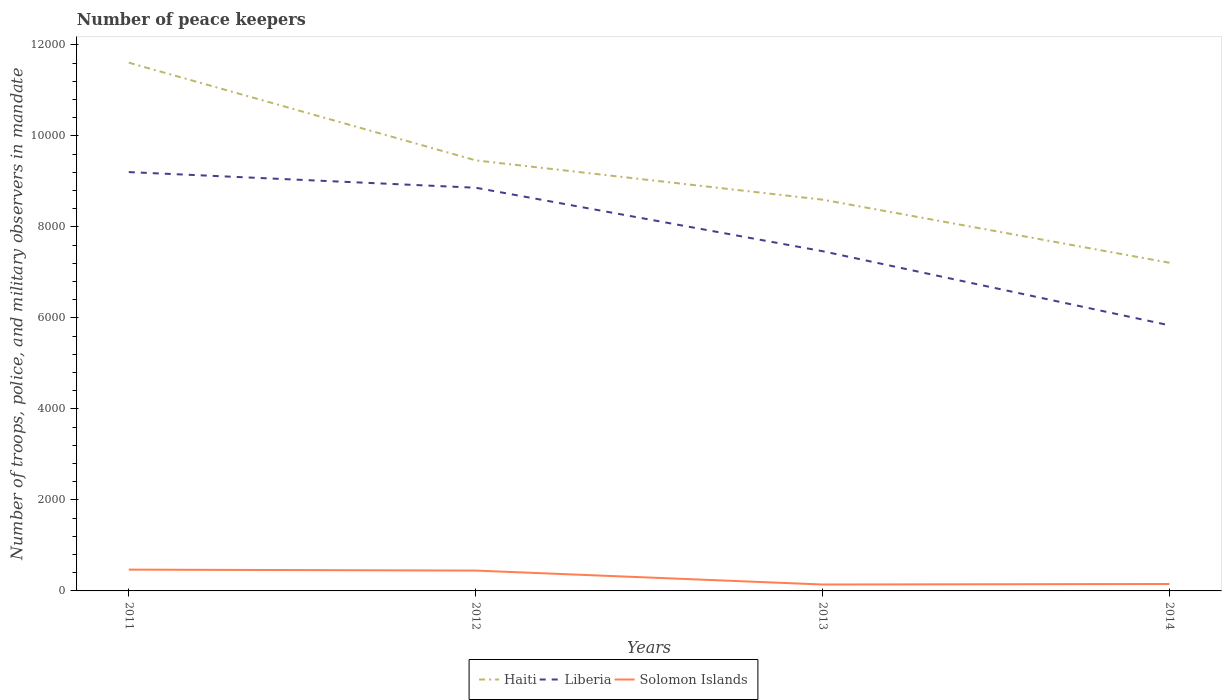Does the line corresponding to Haiti intersect with the line corresponding to Solomon Islands?
Offer a terse response. No. Is the number of lines equal to the number of legend labels?
Your answer should be very brief. Yes. Across all years, what is the maximum number of peace keepers in in Solomon Islands?
Keep it short and to the point. 141. In which year was the number of peace keepers in in Liberia maximum?
Ensure brevity in your answer.  2014. What is the total number of peace keepers in in Liberia in the graph?
Provide a short and direct response. 1395. What is the difference between the highest and the second highest number of peace keepers in in Solomon Islands?
Your answer should be very brief. 327. What is the difference between the highest and the lowest number of peace keepers in in Liberia?
Your answer should be compact. 2. What is the difference between two consecutive major ticks on the Y-axis?
Provide a short and direct response. 2000. Are the values on the major ticks of Y-axis written in scientific E-notation?
Your response must be concise. No. Does the graph contain any zero values?
Ensure brevity in your answer.  No. Does the graph contain grids?
Your answer should be compact. No. Where does the legend appear in the graph?
Your answer should be very brief. Bottom center. What is the title of the graph?
Your answer should be compact. Number of peace keepers. Does "Fragile and conflict affected situations" appear as one of the legend labels in the graph?
Your answer should be very brief. No. What is the label or title of the Y-axis?
Your answer should be compact. Number of troops, police, and military observers in mandate. What is the Number of troops, police, and military observers in mandate of Haiti in 2011?
Provide a succinct answer. 1.16e+04. What is the Number of troops, police, and military observers in mandate in Liberia in 2011?
Your answer should be compact. 9206. What is the Number of troops, police, and military observers in mandate in Solomon Islands in 2011?
Keep it short and to the point. 468. What is the Number of troops, police, and military observers in mandate in Haiti in 2012?
Your answer should be compact. 9464. What is the Number of troops, police, and military observers in mandate of Liberia in 2012?
Keep it short and to the point. 8862. What is the Number of troops, police, and military observers in mandate of Solomon Islands in 2012?
Make the answer very short. 447. What is the Number of troops, police, and military observers in mandate of Haiti in 2013?
Provide a short and direct response. 8600. What is the Number of troops, police, and military observers in mandate in Liberia in 2013?
Offer a terse response. 7467. What is the Number of troops, police, and military observers in mandate in Solomon Islands in 2013?
Keep it short and to the point. 141. What is the Number of troops, police, and military observers in mandate in Haiti in 2014?
Keep it short and to the point. 7213. What is the Number of troops, police, and military observers in mandate of Liberia in 2014?
Ensure brevity in your answer.  5838. What is the Number of troops, police, and military observers in mandate in Solomon Islands in 2014?
Offer a terse response. 152. Across all years, what is the maximum Number of troops, police, and military observers in mandate in Haiti?
Keep it short and to the point. 1.16e+04. Across all years, what is the maximum Number of troops, police, and military observers in mandate of Liberia?
Offer a terse response. 9206. Across all years, what is the maximum Number of troops, police, and military observers in mandate of Solomon Islands?
Keep it short and to the point. 468. Across all years, what is the minimum Number of troops, police, and military observers in mandate of Haiti?
Provide a succinct answer. 7213. Across all years, what is the minimum Number of troops, police, and military observers in mandate in Liberia?
Make the answer very short. 5838. Across all years, what is the minimum Number of troops, police, and military observers in mandate in Solomon Islands?
Give a very brief answer. 141. What is the total Number of troops, police, and military observers in mandate in Haiti in the graph?
Ensure brevity in your answer.  3.69e+04. What is the total Number of troops, police, and military observers in mandate of Liberia in the graph?
Keep it short and to the point. 3.14e+04. What is the total Number of troops, police, and military observers in mandate in Solomon Islands in the graph?
Your response must be concise. 1208. What is the difference between the Number of troops, police, and military observers in mandate of Haiti in 2011 and that in 2012?
Keep it short and to the point. 2147. What is the difference between the Number of troops, police, and military observers in mandate of Liberia in 2011 and that in 2012?
Your response must be concise. 344. What is the difference between the Number of troops, police, and military observers in mandate in Haiti in 2011 and that in 2013?
Make the answer very short. 3011. What is the difference between the Number of troops, police, and military observers in mandate of Liberia in 2011 and that in 2013?
Provide a succinct answer. 1739. What is the difference between the Number of troops, police, and military observers in mandate in Solomon Islands in 2011 and that in 2013?
Offer a very short reply. 327. What is the difference between the Number of troops, police, and military observers in mandate of Haiti in 2011 and that in 2014?
Keep it short and to the point. 4398. What is the difference between the Number of troops, police, and military observers in mandate in Liberia in 2011 and that in 2014?
Your response must be concise. 3368. What is the difference between the Number of troops, police, and military observers in mandate in Solomon Islands in 2011 and that in 2014?
Ensure brevity in your answer.  316. What is the difference between the Number of troops, police, and military observers in mandate of Haiti in 2012 and that in 2013?
Keep it short and to the point. 864. What is the difference between the Number of troops, police, and military observers in mandate in Liberia in 2012 and that in 2013?
Give a very brief answer. 1395. What is the difference between the Number of troops, police, and military observers in mandate of Solomon Islands in 2012 and that in 2013?
Offer a very short reply. 306. What is the difference between the Number of troops, police, and military observers in mandate in Haiti in 2012 and that in 2014?
Ensure brevity in your answer.  2251. What is the difference between the Number of troops, police, and military observers in mandate in Liberia in 2012 and that in 2014?
Your response must be concise. 3024. What is the difference between the Number of troops, police, and military observers in mandate of Solomon Islands in 2012 and that in 2014?
Your answer should be compact. 295. What is the difference between the Number of troops, police, and military observers in mandate in Haiti in 2013 and that in 2014?
Provide a succinct answer. 1387. What is the difference between the Number of troops, police, and military observers in mandate in Liberia in 2013 and that in 2014?
Give a very brief answer. 1629. What is the difference between the Number of troops, police, and military observers in mandate of Haiti in 2011 and the Number of troops, police, and military observers in mandate of Liberia in 2012?
Make the answer very short. 2749. What is the difference between the Number of troops, police, and military observers in mandate of Haiti in 2011 and the Number of troops, police, and military observers in mandate of Solomon Islands in 2012?
Your answer should be very brief. 1.12e+04. What is the difference between the Number of troops, police, and military observers in mandate in Liberia in 2011 and the Number of troops, police, and military observers in mandate in Solomon Islands in 2012?
Your answer should be very brief. 8759. What is the difference between the Number of troops, police, and military observers in mandate in Haiti in 2011 and the Number of troops, police, and military observers in mandate in Liberia in 2013?
Your response must be concise. 4144. What is the difference between the Number of troops, police, and military observers in mandate of Haiti in 2011 and the Number of troops, police, and military observers in mandate of Solomon Islands in 2013?
Give a very brief answer. 1.15e+04. What is the difference between the Number of troops, police, and military observers in mandate in Liberia in 2011 and the Number of troops, police, and military observers in mandate in Solomon Islands in 2013?
Your answer should be very brief. 9065. What is the difference between the Number of troops, police, and military observers in mandate of Haiti in 2011 and the Number of troops, police, and military observers in mandate of Liberia in 2014?
Provide a succinct answer. 5773. What is the difference between the Number of troops, police, and military observers in mandate in Haiti in 2011 and the Number of troops, police, and military observers in mandate in Solomon Islands in 2014?
Your answer should be compact. 1.15e+04. What is the difference between the Number of troops, police, and military observers in mandate in Liberia in 2011 and the Number of troops, police, and military observers in mandate in Solomon Islands in 2014?
Your answer should be compact. 9054. What is the difference between the Number of troops, police, and military observers in mandate in Haiti in 2012 and the Number of troops, police, and military observers in mandate in Liberia in 2013?
Your response must be concise. 1997. What is the difference between the Number of troops, police, and military observers in mandate in Haiti in 2012 and the Number of troops, police, and military observers in mandate in Solomon Islands in 2013?
Offer a very short reply. 9323. What is the difference between the Number of troops, police, and military observers in mandate of Liberia in 2012 and the Number of troops, police, and military observers in mandate of Solomon Islands in 2013?
Your answer should be compact. 8721. What is the difference between the Number of troops, police, and military observers in mandate of Haiti in 2012 and the Number of troops, police, and military observers in mandate of Liberia in 2014?
Provide a short and direct response. 3626. What is the difference between the Number of troops, police, and military observers in mandate of Haiti in 2012 and the Number of troops, police, and military observers in mandate of Solomon Islands in 2014?
Your answer should be compact. 9312. What is the difference between the Number of troops, police, and military observers in mandate of Liberia in 2012 and the Number of troops, police, and military observers in mandate of Solomon Islands in 2014?
Ensure brevity in your answer.  8710. What is the difference between the Number of troops, police, and military observers in mandate of Haiti in 2013 and the Number of troops, police, and military observers in mandate of Liberia in 2014?
Your response must be concise. 2762. What is the difference between the Number of troops, police, and military observers in mandate of Haiti in 2013 and the Number of troops, police, and military observers in mandate of Solomon Islands in 2014?
Your answer should be very brief. 8448. What is the difference between the Number of troops, police, and military observers in mandate of Liberia in 2013 and the Number of troops, police, and military observers in mandate of Solomon Islands in 2014?
Your response must be concise. 7315. What is the average Number of troops, police, and military observers in mandate of Haiti per year?
Provide a succinct answer. 9222. What is the average Number of troops, police, and military observers in mandate in Liberia per year?
Make the answer very short. 7843.25. What is the average Number of troops, police, and military observers in mandate in Solomon Islands per year?
Give a very brief answer. 302. In the year 2011, what is the difference between the Number of troops, police, and military observers in mandate in Haiti and Number of troops, police, and military observers in mandate in Liberia?
Give a very brief answer. 2405. In the year 2011, what is the difference between the Number of troops, police, and military observers in mandate in Haiti and Number of troops, police, and military observers in mandate in Solomon Islands?
Keep it short and to the point. 1.11e+04. In the year 2011, what is the difference between the Number of troops, police, and military observers in mandate of Liberia and Number of troops, police, and military observers in mandate of Solomon Islands?
Keep it short and to the point. 8738. In the year 2012, what is the difference between the Number of troops, police, and military observers in mandate of Haiti and Number of troops, police, and military observers in mandate of Liberia?
Offer a terse response. 602. In the year 2012, what is the difference between the Number of troops, police, and military observers in mandate in Haiti and Number of troops, police, and military observers in mandate in Solomon Islands?
Your answer should be compact. 9017. In the year 2012, what is the difference between the Number of troops, police, and military observers in mandate of Liberia and Number of troops, police, and military observers in mandate of Solomon Islands?
Keep it short and to the point. 8415. In the year 2013, what is the difference between the Number of troops, police, and military observers in mandate of Haiti and Number of troops, police, and military observers in mandate of Liberia?
Offer a terse response. 1133. In the year 2013, what is the difference between the Number of troops, police, and military observers in mandate of Haiti and Number of troops, police, and military observers in mandate of Solomon Islands?
Offer a terse response. 8459. In the year 2013, what is the difference between the Number of troops, police, and military observers in mandate in Liberia and Number of troops, police, and military observers in mandate in Solomon Islands?
Offer a very short reply. 7326. In the year 2014, what is the difference between the Number of troops, police, and military observers in mandate in Haiti and Number of troops, police, and military observers in mandate in Liberia?
Provide a succinct answer. 1375. In the year 2014, what is the difference between the Number of troops, police, and military observers in mandate of Haiti and Number of troops, police, and military observers in mandate of Solomon Islands?
Your answer should be very brief. 7061. In the year 2014, what is the difference between the Number of troops, police, and military observers in mandate in Liberia and Number of troops, police, and military observers in mandate in Solomon Islands?
Give a very brief answer. 5686. What is the ratio of the Number of troops, police, and military observers in mandate in Haiti in 2011 to that in 2012?
Your answer should be compact. 1.23. What is the ratio of the Number of troops, police, and military observers in mandate of Liberia in 2011 to that in 2012?
Your answer should be very brief. 1.04. What is the ratio of the Number of troops, police, and military observers in mandate in Solomon Islands in 2011 to that in 2012?
Offer a terse response. 1.05. What is the ratio of the Number of troops, police, and military observers in mandate of Haiti in 2011 to that in 2013?
Provide a short and direct response. 1.35. What is the ratio of the Number of troops, police, and military observers in mandate of Liberia in 2011 to that in 2013?
Your answer should be very brief. 1.23. What is the ratio of the Number of troops, police, and military observers in mandate in Solomon Islands in 2011 to that in 2013?
Offer a terse response. 3.32. What is the ratio of the Number of troops, police, and military observers in mandate of Haiti in 2011 to that in 2014?
Give a very brief answer. 1.61. What is the ratio of the Number of troops, police, and military observers in mandate of Liberia in 2011 to that in 2014?
Your response must be concise. 1.58. What is the ratio of the Number of troops, police, and military observers in mandate of Solomon Islands in 2011 to that in 2014?
Your answer should be compact. 3.08. What is the ratio of the Number of troops, police, and military observers in mandate in Haiti in 2012 to that in 2013?
Your response must be concise. 1.1. What is the ratio of the Number of troops, police, and military observers in mandate in Liberia in 2012 to that in 2013?
Your response must be concise. 1.19. What is the ratio of the Number of troops, police, and military observers in mandate in Solomon Islands in 2012 to that in 2013?
Keep it short and to the point. 3.17. What is the ratio of the Number of troops, police, and military observers in mandate of Haiti in 2012 to that in 2014?
Your answer should be compact. 1.31. What is the ratio of the Number of troops, police, and military observers in mandate in Liberia in 2012 to that in 2014?
Make the answer very short. 1.52. What is the ratio of the Number of troops, police, and military observers in mandate of Solomon Islands in 2012 to that in 2014?
Make the answer very short. 2.94. What is the ratio of the Number of troops, police, and military observers in mandate in Haiti in 2013 to that in 2014?
Your answer should be very brief. 1.19. What is the ratio of the Number of troops, police, and military observers in mandate of Liberia in 2013 to that in 2014?
Offer a very short reply. 1.28. What is the ratio of the Number of troops, police, and military observers in mandate in Solomon Islands in 2013 to that in 2014?
Provide a short and direct response. 0.93. What is the difference between the highest and the second highest Number of troops, police, and military observers in mandate of Haiti?
Give a very brief answer. 2147. What is the difference between the highest and the second highest Number of troops, police, and military observers in mandate in Liberia?
Your response must be concise. 344. What is the difference between the highest and the lowest Number of troops, police, and military observers in mandate in Haiti?
Keep it short and to the point. 4398. What is the difference between the highest and the lowest Number of troops, police, and military observers in mandate in Liberia?
Provide a succinct answer. 3368. What is the difference between the highest and the lowest Number of troops, police, and military observers in mandate of Solomon Islands?
Keep it short and to the point. 327. 